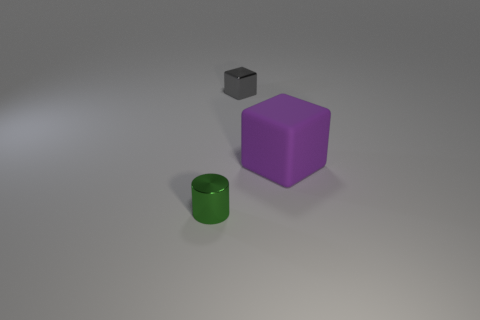Add 3 small gray shiny things. How many objects exist? 6 Subtract all blocks. How many objects are left? 1 Add 1 purple cubes. How many purple cubes exist? 2 Subtract 0 red cylinders. How many objects are left? 3 Subtract all green things. Subtract all large purple objects. How many objects are left? 1 Add 1 tiny gray blocks. How many tiny gray blocks are left? 2 